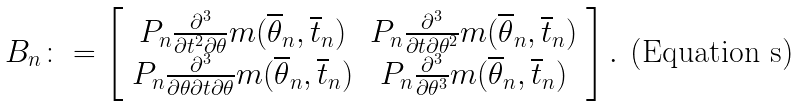<formula> <loc_0><loc_0><loc_500><loc_500>B _ { n } \colon = \left [ \begin{array} { c c } P _ { n } \frac { \partial ^ { 3 } } { \partial t ^ { 2 } \partial \theta } m ( \overline { \theta } _ { n } , \overline { t } _ { n } ) & P _ { n } \frac { \partial ^ { 3 } } { \partial t \partial \theta ^ { 2 } } m ( \overline { \theta } _ { n } , \overline { t } _ { n } ) \\ P _ { n } \frac { \partial ^ { 3 } } { \partial \theta \partial t \partial \theta } m ( \overline { \theta } _ { n } , \overline { t } _ { n } ) & P _ { n } \frac { \partial ^ { 3 } } { \partial \theta ^ { 3 } } m ( \overline { \theta } _ { n } , \overline { t } _ { n } ) \end{array} \right ] .</formula> 